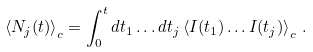Convert formula to latex. <formula><loc_0><loc_0><loc_500><loc_500>\left < N _ { j } ( t ) \right > _ { c } = \int _ { 0 } ^ { t } d t _ { 1 } \dots d t _ { j } \left < I ( t _ { 1 } ) \dots I ( t _ { j } ) \right > _ { c } \, .</formula> 